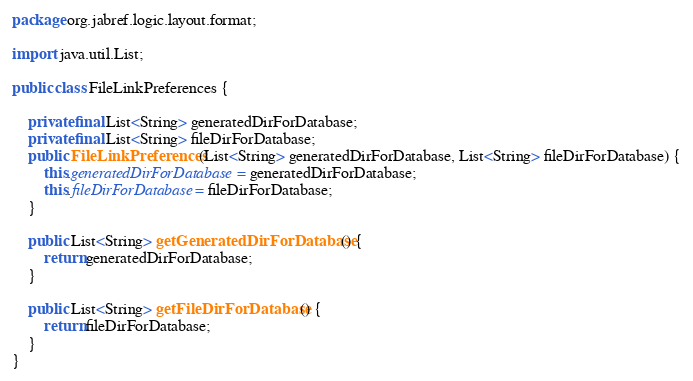<code> <loc_0><loc_0><loc_500><loc_500><_Java_>package org.jabref.logic.layout.format;

import java.util.List;

public class FileLinkPreferences {

    private final List<String> generatedDirForDatabase;
    private final List<String> fileDirForDatabase;
    public FileLinkPreferences(List<String> generatedDirForDatabase, List<String> fileDirForDatabase) {
        this.generatedDirForDatabase = generatedDirForDatabase;
        this.fileDirForDatabase = fileDirForDatabase;
    }

    public List<String> getGeneratedDirForDatabase() {
        return generatedDirForDatabase;
    }

    public List<String> getFileDirForDatabase() {
        return fileDirForDatabase;
    }
}
</code> 